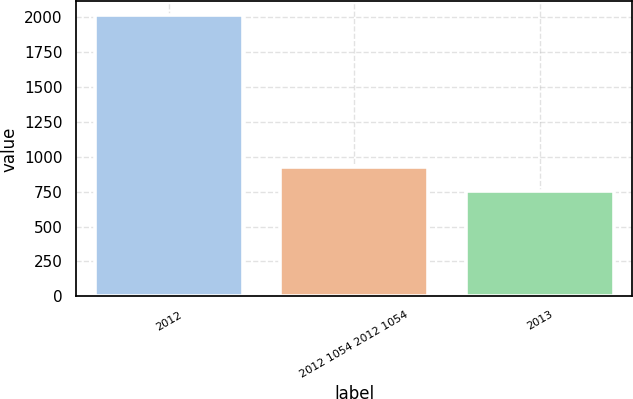Convert chart. <chart><loc_0><loc_0><loc_500><loc_500><bar_chart><fcel>2012<fcel>2012 1054 2012 1054<fcel>2013<nl><fcel>2014<fcel>924<fcel>755<nl></chart> 